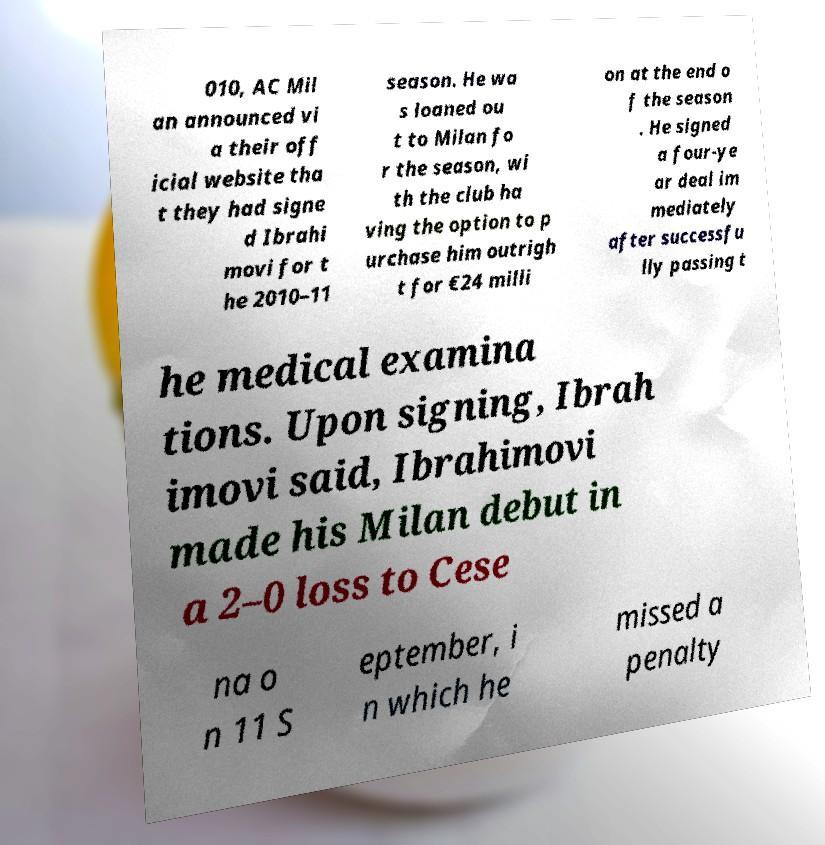There's text embedded in this image that I need extracted. Can you transcribe it verbatim? 010, AC Mil an announced vi a their off icial website tha t they had signe d Ibrahi movi for t he 2010–11 season. He wa s loaned ou t to Milan fo r the season, wi th the club ha ving the option to p urchase him outrigh t for €24 milli on at the end o f the season . He signed a four-ye ar deal im mediately after successfu lly passing t he medical examina tions. Upon signing, Ibrah imovi said, Ibrahimovi made his Milan debut in a 2–0 loss to Cese na o n 11 S eptember, i n which he missed a penalty 